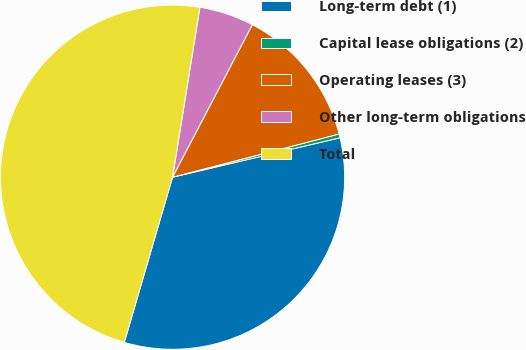<chart> <loc_0><loc_0><loc_500><loc_500><pie_chart><fcel>Long-term debt (1)<fcel>Capital lease obligations (2)<fcel>Operating leases (3)<fcel>Other long-term obligations<fcel>Total<nl><fcel>33.2%<fcel>0.36%<fcel>13.29%<fcel>5.13%<fcel>48.02%<nl></chart> 